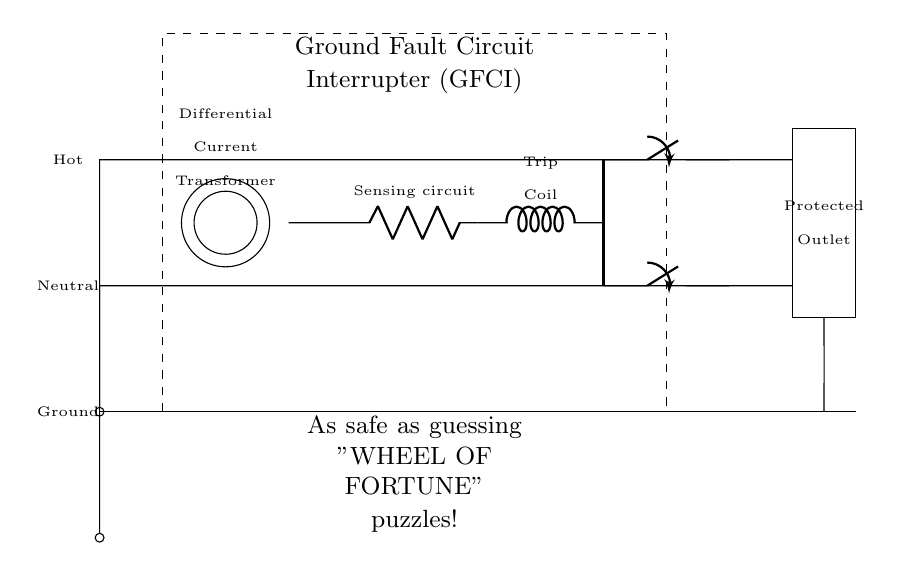what is the main purpose of the GFCI in this circuit? The main purpose of the Ground Fault Circuit Interrupter (GFCI) is to protect against electrical shock by sensing differences in current and interrupting the circuit if a ground fault is detected.
Answer: protect against electrical shock what component detects ground faults in this circuit? The differential current transformer detects ground faults by measuring the difference in current between the hot and neutral wires.
Answer: differential current transformer how many outlets are protected by this GFCI? The GFCI protects two outlets that are connected to its output, one for hot and one for neutral.
Answer: two outlets what type of switch is used in this circuit? The switches used in this circuit are standard mechanical switches, which connect and disconnect the power to the outlets.
Answer: mechanical switches what happens when the trip coil is activated? When the trip coil is activated, it mechanically opens the switches, interrupting the power supply to the outlets to protect against shocks.
Answer: interrupts power supply which component mechanically links the trip coil to the switches? The mechanical linkage connects the trip coil to the switches, enabling it to open the switches when activated.
Answer: mechanical linkage 